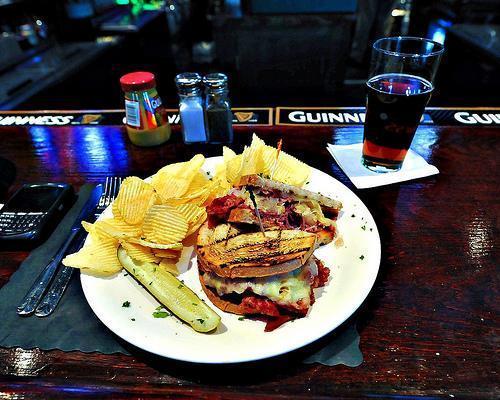How many pieces of silverware are shown?
Give a very brief answer. 2. How many slices of pickle are shown?
Give a very brief answer. 1. 